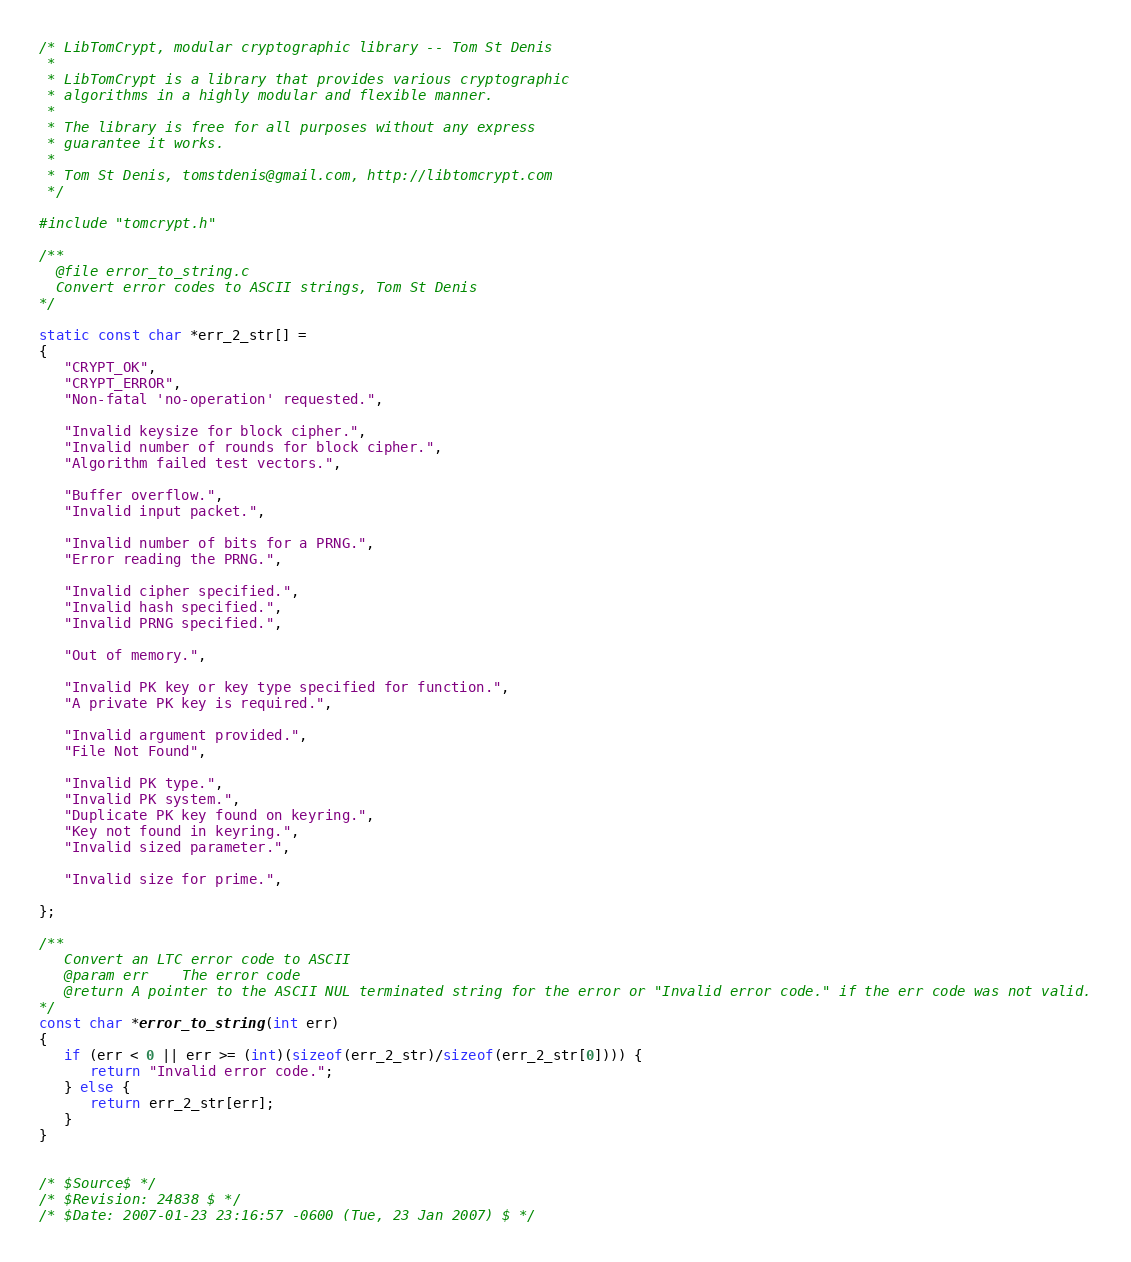Convert code to text. <code><loc_0><loc_0><loc_500><loc_500><_C_>/* LibTomCrypt, modular cryptographic library -- Tom St Denis
 *
 * LibTomCrypt is a library that provides various cryptographic
 * algorithms in a highly modular and flexible manner.
 *
 * The library is free for all purposes without any express
 * guarantee it works.
 *
 * Tom St Denis, tomstdenis@gmail.com, http://libtomcrypt.com
 */

#include "tomcrypt.h"

/**
  @file error_to_string.c
  Convert error codes to ASCII strings, Tom St Denis
*/

static const char *err_2_str[] =
{
   "CRYPT_OK",
   "CRYPT_ERROR",
   "Non-fatal 'no-operation' requested.",

   "Invalid keysize for block cipher.",
   "Invalid number of rounds for block cipher.",
   "Algorithm failed test vectors.",

   "Buffer overflow.",
   "Invalid input packet.",

   "Invalid number of bits for a PRNG.",
   "Error reading the PRNG.",

   "Invalid cipher specified.",
   "Invalid hash specified.",
   "Invalid PRNG specified.",

   "Out of memory.",

   "Invalid PK key or key type specified for function.",
   "A private PK key is required.",

   "Invalid argument provided.",
   "File Not Found",

   "Invalid PK type.",
   "Invalid PK system.",
   "Duplicate PK key found on keyring.",
   "Key not found in keyring.",
   "Invalid sized parameter.",

   "Invalid size for prime.",

};

/**
   Convert an LTC error code to ASCII
   @param err    The error code
   @return A pointer to the ASCII NUL terminated string for the error or "Invalid error code." if the err code was not valid.
*/
const char *error_to_string(int err)
{
   if (err < 0 || err >= (int)(sizeof(err_2_str)/sizeof(err_2_str[0]))) {
      return "Invalid error code.";
   } else {
      return err_2_str[err];
   }   
}


/* $Source$ */
/* $Revision: 24838 $ */
/* $Date: 2007-01-23 23:16:57 -0600 (Tue, 23 Jan 2007) $ */
</code> 